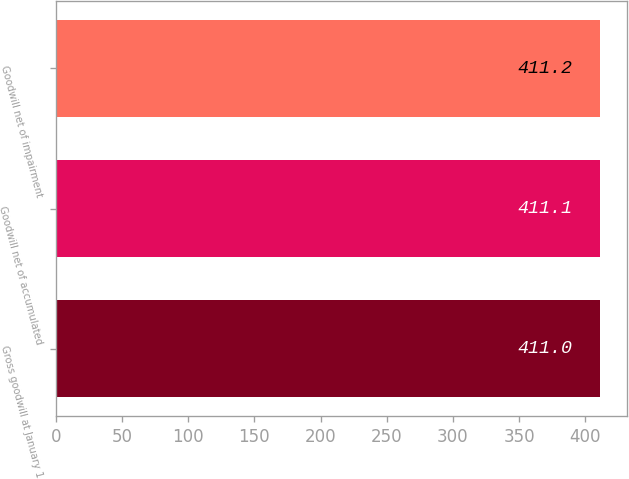Convert chart. <chart><loc_0><loc_0><loc_500><loc_500><bar_chart><fcel>Gross goodwill at January 1<fcel>Goodwill net of accumulated<fcel>Goodwill net of impairment<nl><fcel>411<fcel>411.1<fcel>411.2<nl></chart> 